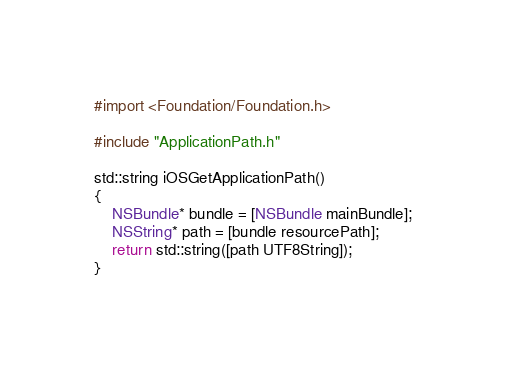Convert code to text. <code><loc_0><loc_0><loc_500><loc_500><_ObjectiveC_>#import <Foundation/Foundation.h>

#include "ApplicationPath.h"

std::string iOSGetApplicationPath()
{
    NSBundle* bundle = [NSBundle mainBundle];
    NSString* path = [bundle resourcePath];
    return std::string([path UTF8String]);
}
</code> 